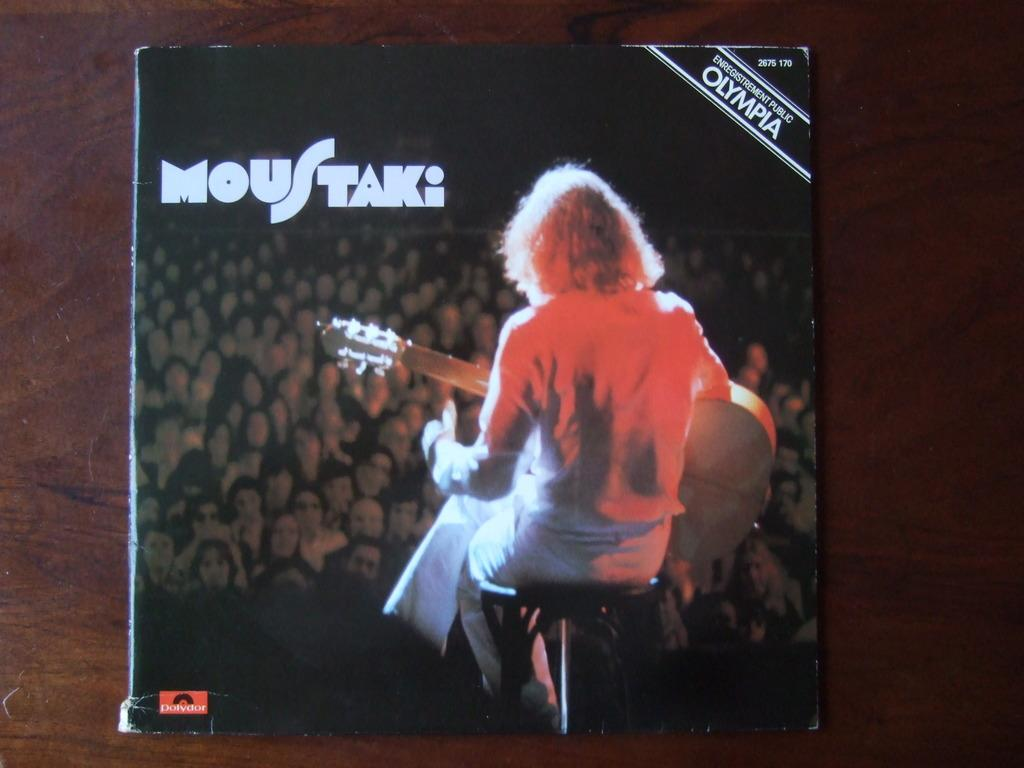<image>
Describe the image concisely. An album cover showing a person with a guitar is called Moustaki and has Olympia written in the corner. 